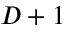Convert formula to latex. <formula><loc_0><loc_0><loc_500><loc_500>D + 1</formula> 